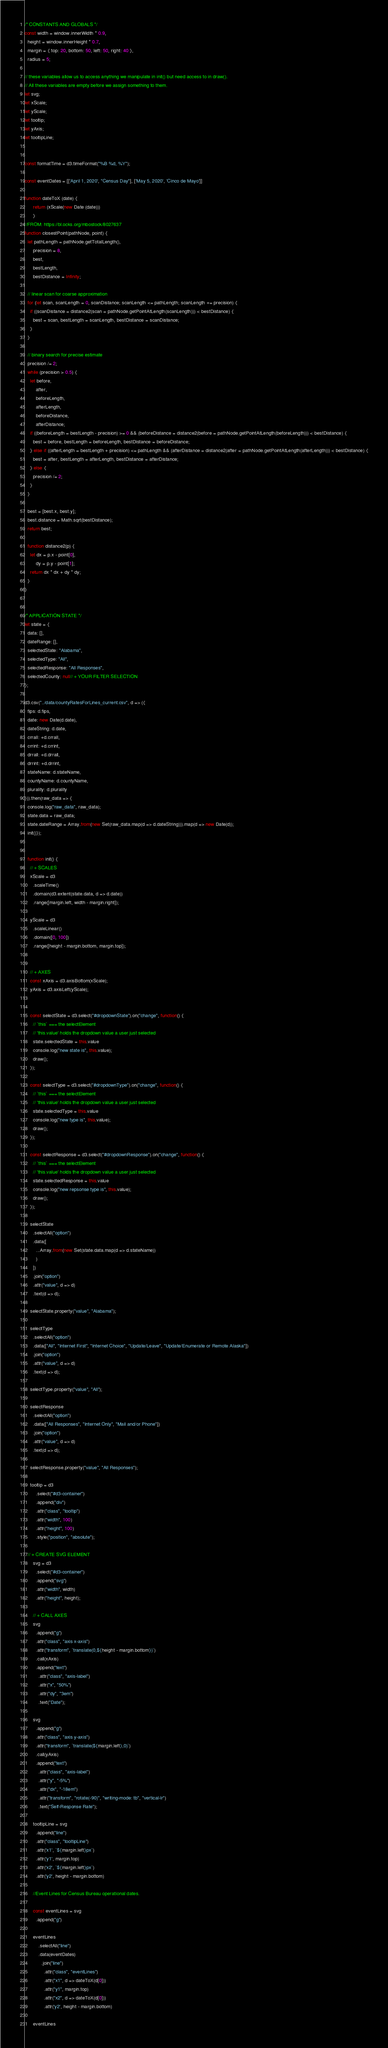<code> <loc_0><loc_0><loc_500><loc_500><_JavaScript_>/* CONSTANTS AND GLOBALS */
const width = window.innerWidth * 0.9,
  height = window.innerHeight * 0.7,
  margin = { top: 20, bottom: 50, left: 50, right: 40 },
  radius = 5;

// these variables allow us to access anything we manipulate in init() but need access to in draw().
// All these variables are empty before we assign something to them.
let svg;
let xScale;
let yScale;
let tooltip;
let yAxis;
let tooltipLine;


const formatTime = d3.timeFormat("%B %d, %Y");

const eventDates = [['April 1, 2020', "Census Day"], ['May 5, 2020', 'Cinco de Mayo']]

function dateToX (date) {
      return (xScale(new Date (date)))
      }
//FROM: https://bl.ocks.org/mbostock/8027637
function closestPoint(pathNode, point) {
  let pathLength = pathNode.getTotalLength(),
      precision = 8,
      best,
      bestLength,
      bestDistance = Infinity;

  // linear scan for coarse approximation
  for (let scan, scanLength = 0, scanDistance; scanLength <= pathLength; scanLength += precision) {
    if ((scanDistance = distance2(scan = pathNode.getPointAtLength(scanLength))) < bestDistance) {
      best = scan, bestLength = scanLength, bestDistance = scanDistance;
    }
  }

  // binary search for precise estimate
  precision /= 2;
  while (precision > 0.5) {
    let before,
        after,
        beforeLength,
        afterLength,
        beforeDistance,
        afterDistance;
    if ((beforeLength = bestLength - precision) >= 0 && (beforeDistance = distance2(before = pathNode.getPointAtLength(beforeLength))) < bestDistance) {
      best = before, bestLength = beforeLength, bestDistance = beforeDistance;
    } else if ((afterLength = bestLength + precision) <= pathLength && (afterDistance = distance2(after = pathNode.getPointAtLength(afterLength))) < bestDistance) {
      best = after, bestLength = afterLength, bestDistance = afterDistance;
    } else {
      precision /= 2;
    }
  }

  best = [best.x, best.y];
  best.distance = Math.sqrt(bestDistance);
  return best;

  function distance2(p) {
    let dx = p.x - point[0],
        dy = p.y - point[1];
    return dx * dx + dy * dy;
  }
}


/* APPLICATION STATE */
let state = {
  data: [],
  dateRange: [],
  selectedState: "Alabama",
  selectedType: "All",
  selectedResponse: "All Responses", 
  selectedCounty: null// + YOUR FILTER SELECTION
};

d3.csv("../data/countyRatesForLines_current.csv", d => ({
  fips: d.fips,
  date: new Date(d.date),
  dateString: d.date,
  crrall: +d.crrall,
  crrint: +d.crrint,
  drrall: +d.drrall,
  drrint: +d.drrint,
  stateName: d.stateName,
  countyName: d.countyName,
  plurality: d.plurality
})).then(raw_data => {
  console.log("raw_data", raw_data);
  state.data = raw_data;
  state.dateRange = Array.from(new Set(raw_data.map(d => d.dateString))).map(d => new Date(d));
  init()});
 
  
  function init() {
    // + SCALES
    xScale = d3
      .scaleTime()
      .domain(d3.extent(state.data, d => d.date))
      .range([margin.left, width - margin.right]);  
  
    yScale = d3
      .scaleLinear()
      .domain([0, 100])
      .range([height - margin.bottom, margin.top]);
  
  
    // + AXES
    const xAxis = d3.axisBottom(xScale);
    yAxis = d3.axisLeft(yScale);
      

    const selectState = d3.select("#dropdownState").on("change", function() {
      // `this` === the selectElement
      // 'this.value' holds the dropdown value a user just selected
      state.selectedState = this.value
      console.log("new state is", this.value);
      draw();
    });

    const selectType = d3.select("#dropdownType").on("change", function() {
      // `this` === the selectElement
      // 'this.value' holds the dropdown value a user just selected
      state.selectedType = this.value
      console.log("new type is", this.value);
      draw();
    });

    const selectResponse = d3.select("#dropdownResponse").on("change", function() {
      // `this` === the selectElement
      // 'this.value' holds the dropdown value a user just selected
      state.selectedResponse = this.value
      console.log("new repsonse type is", this.value);
      draw();
    });

    selectState
      .selectAll("option")
      .data([
        ...Array.from(new Set(state.data.map(d => d.stateName))
        )
      ])
      .join("option")
      .attr("value", d => d)
      .text(d => d);

    selectState.property("value", "Alabama");

    selectType
      .selectAll("option")
      .data(["All", "Internet First", "Internet Choice", "Update/Leave", "Update/Enumerate or Remote Alaska"])
      .join("option")
      .attr("value", d => d)
      .text(d => d);

    selectType.property("value", "All");

    selectResponse
      .selectAll("option")
      .data(["All Responses", "Internet Only", "Mail and/or Phone"])
      .join("option")
      .attr("value", d => d)
      .text(d => d);

    selectResponse.property("value", "All Responses");

    tooltip = d3
        .select("#d3-container")
        .append("div")
        .attr("class", "tooltip")
        .attr("width", 100)
        .attr("height", 100)
        .style("position", "absolute");  

  // + CREATE SVG ELEMENT
      svg = d3
        .select("#d3-container")
        .append("svg")
        .attr("width", width)
        .attr("height", height);

      // + CALL AXES
      svg
        .append("g")
        .attr("class", "axis x-axis")
        .attr("transform", `translate(0,${height - margin.bottom})`)
        .call(xAxis)
        .append("text")
          .attr("class", "axis-label")
          .attr("x", "50%")
          .attr("dy", "3em")
          .text("Date");

      svg
        .append("g")
        .attr("class", "axis y-axis")
        .attr("transform", `translate(${margin.left},0)`)
        .call(yAxis)
        .append("text")
          .attr("class", "axis-label")
          .attr("y", "-5%")
          .attr("dx", "-18em")
          .attr("transform", "rotate(-90)", "writing-mode: tb", "vertical-lr")
          .text("Self-Response Rate");

      tooltipLine = svg
        .append("line")
        .attr("class", "tooltipLine")
        .attr('x1', `${margin.left}px`)
        .attr('y1', margin.top)
        .attr('x2', `${margin.left}px`)
        .attr('y2', height - margin.bottom)

      //Event Lines for Census Bureau operational dates.
      
      const eventLines = svg
        .append("g")

      eventLines
          .selectAll("line")
          .data(eventDates)
            .join("line")
              .attr("class", "eventLines")
              .attr("x1", d => dateToX(d[0]))
              .attr("y1", margin.top)
              .attr("x2", d => dateToX(d[0]))
              .attr('y2', height - margin.bottom) 

      eventLines</code> 